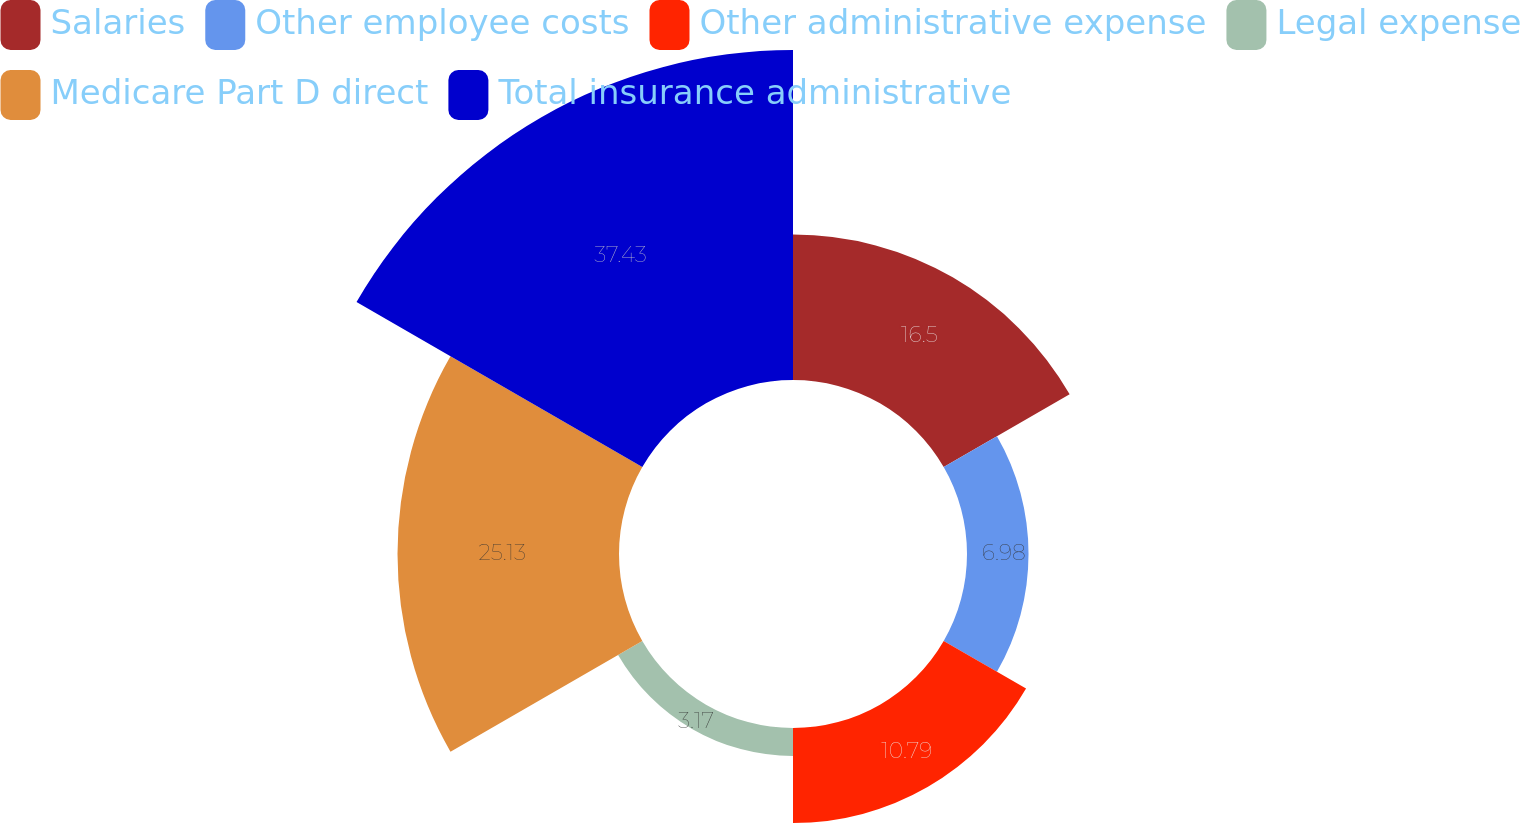<chart> <loc_0><loc_0><loc_500><loc_500><pie_chart><fcel>Salaries<fcel>Other employee costs<fcel>Other administrative expense<fcel>Legal expense<fcel>Medicare Part D direct<fcel>Total insurance administrative<nl><fcel>16.5%<fcel>6.98%<fcel>10.79%<fcel>3.17%<fcel>25.13%<fcel>37.44%<nl></chart> 